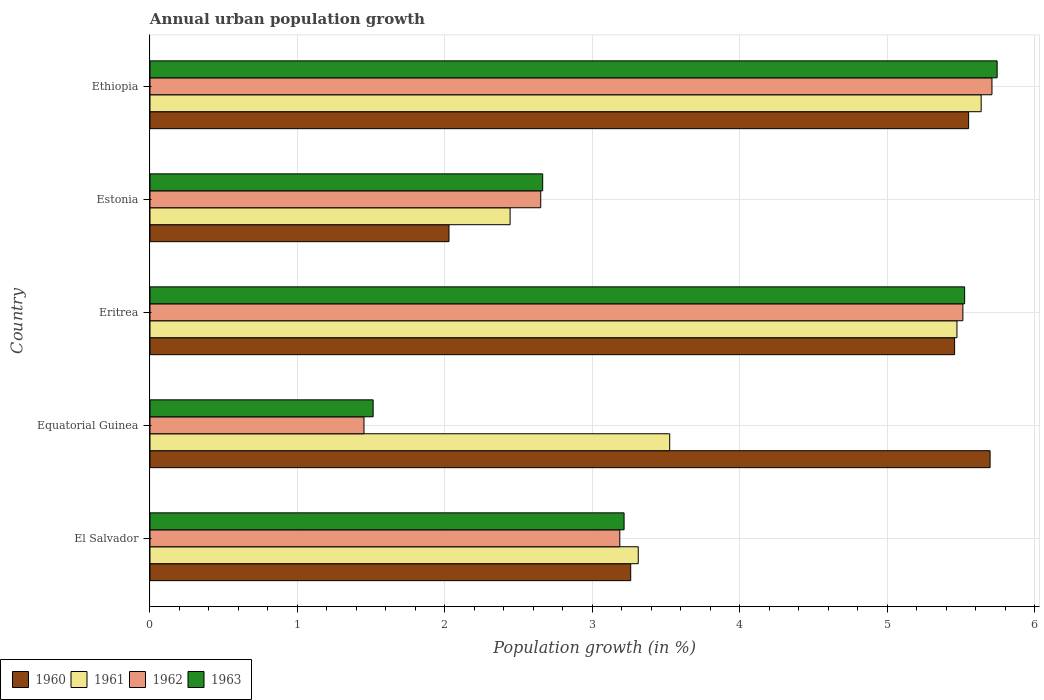How many different coloured bars are there?
Offer a very short reply. 4. What is the label of the 2nd group of bars from the top?
Keep it short and to the point. Estonia. In how many cases, is the number of bars for a given country not equal to the number of legend labels?
Your response must be concise. 0. What is the percentage of urban population growth in 1962 in Estonia?
Make the answer very short. 2.65. Across all countries, what is the maximum percentage of urban population growth in 1962?
Provide a succinct answer. 5.71. Across all countries, what is the minimum percentage of urban population growth in 1960?
Your answer should be compact. 2.03. In which country was the percentage of urban population growth in 1961 maximum?
Keep it short and to the point. Ethiopia. In which country was the percentage of urban population growth in 1961 minimum?
Provide a short and direct response. Estonia. What is the total percentage of urban population growth in 1963 in the graph?
Provide a short and direct response. 18.66. What is the difference between the percentage of urban population growth in 1961 in Estonia and that in Ethiopia?
Your answer should be compact. -3.2. What is the difference between the percentage of urban population growth in 1962 in Ethiopia and the percentage of urban population growth in 1961 in Equatorial Guinea?
Make the answer very short. 2.19. What is the average percentage of urban population growth in 1960 per country?
Give a very brief answer. 4.4. What is the difference between the percentage of urban population growth in 1960 and percentage of urban population growth in 1962 in Estonia?
Provide a succinct answer. -0.62. In how many countries, is the percentage of urban population growth in 1962 greater than 3.4 %?
Ensure brevity in your answer.  2. What is the ratio of the percentage of urban population growth in 1960 in El Salvador to that in Eritrea?
Keep it short and to the point. 0.6. Is the percentage of urban population growth in 1962 in El Salvador less than that in Eritrea?
Give a very brief answer. Yes. What is the difference between the highest and the second highest percentage of urban population growth in 1961?
Provide a succinct answer. 0.16. What is the difference between the highest and the lowest percentage of urban population growth in 1961?
Your response must be concise. 3.2. Is the sum of the percentage of urban population growth in 1963 in Eritrea and Ethiopia greater than the maximum percentage of urban population growth in 1962 across all countries?
Ensure brevity in your answer.  Yes. What does the 2nd bar from the bottom in Ethiopia represents?
Offer a terse response. 1961. Is it the case that in every country, the sum of the percentage of urban population growth in 1961 and percentage of urban population growth in 1960 is greater than the percentage of urban population growth in 1963?
Your answer should be compact. Yes. How many countries are there in the graph?
Offer a terse response. 5. What is the difference between two consecutive major ticks on the X-axis?
Your response must be concise. 1. Are the values on the major ticks of X-axis written in scientific E-notation?
Your answer should be very brief. No. How many legend labels are there?
Offer a terse response. 4. What is the title of the graph?
Offer a terse response. Annual urban population growth. Does "1985" appear as one of the legend labels in the graph?
Offer a very short reply. No. What is the label or title of the X-axis?
Your response must be concise. Population growth (in %). What is the Population growth (in %) of 1960 in El Salvador?
Ensure brevity in your answer.  3.26. What is the Population growth (in %) of 1961 in El Salvador?
Your response must be concise. 3.31. What is the Population growth (in %) in 1962 in El Salvador?
Provide a short and direct response. 3.19. What is the Population growth (in %) in 1963 in El Salvador?
Your response must be concise. 3.22. What is the Population growth (in %) of 1960 in Equatorial Guinea?
Provide a succinct answer. 5.7. What is the Population growth (in %) in 1961 in Equatorial Guinea?
Make the answer very short. 3.53. What is the Population growth (in %) of 1962 in Equatorial Guinea?
Your answer should be compact. 1.45. What is the Population growth (in %) in 1963 in Equatorial Guinea?
Your answer should be very brief. 1.51. What is the Population growth (in %) in 1960 in Eritrea?
Your answer should be very brief. 5.46. What is the Population growth (in %) in 1961 in Eritrea?
Provide a succinct answer. 5.47. What is the Population growth (in %) of 1962 in Eritrea?
Your answer should be very brief. 5.51. What is the Population growth (in %) of 1963 in Eritrea?
Keep it short and to the point. 5.53. What is the Population growth (in %) of 1960 in Estonia?
Offer a very short reply. 2.03. What is the Population growth (in %) in 1961 in Estonia?
Make the answer very short. 2.44. What is the Population growth (in %) in 1962 in Estonia?
Your answer should be compact. 2.65. What is the Population growth (in %) in 1963 in Estonia?
Give a very brief answer. 2.66. What is the Population growth (in %) in 1960 in Ethiopia?
Your response must be concise. 5.55. What is the Population growth (in %) of 1961 in Ethiopia?
Make the answer very short. 5.64. What is the Population growth (in %) of 1962 in Ethiopia?
Offer a terse response. 5.71. What is the Population growth (in %) in 1963 in Ethiopia?
Keep it short and to the point. 5.75. Across all countries, what is the maximum Population growth (in %) of 1960?
Offer a very short reply. 5.7. Across all countries, what is the maximum Population growth (in %) of 1961?
Ensure brevity in your answer.  5.64. Across all countries, what is the maximum Population growth (in %) of 1962?
Provide a short and direct response. 5.71. Across all countries, what is the maximum Population growth (in %) of 1963?
Your answer should be compact. 5.75. Across all countries, what is the minimum Population growth (in %) of 1960?
Your response must be concise. 2.03. Across all countries, what is the minimum Population growth (in %) in 1961?
Ensure brevity in your answer.  2.44. Across all countries, what is the minimum Population growth (in %) of 1962?
Offer a very short reply. 1.45. Across all countries, what is the minimum Population growth (in %) of 1963?
Your response must be concise. 1.51. What is the total Population growth (in %) in 1960 in the graph?
Your response must be concise. 22. What is the total Population growth (in %) in 1961 in the graph?
Offer a very short reply. 20.39. What is the total Population growth (in %) of 1962 in the graph?
Provide a succinct answer. 18.51. What is the total Population growth (in %) in 1963 in the graph?
Ensure brevity in your answer.  18.66. What is the difference between the Population growth (in %) of 1960 in El Salvador and that in Equatorial Guinea?
Give a very brief answer. -2.44. What is the difference between the Population growth (in %) of 1961 in El Salvador and that in Equatorial Guinea?
Offer a terse response. -0.21. What is the difference between the Population growth (in %) in 1962 in El Salvador and that in Equatorial Guinea?
Make the answer very short. 1.74. What is the difference between the Population growth (in %) in 1963 in El Salvador and that in Equatorial Guinea?
Offer a terse response. 1.7. What is the difference between the Population growth (in %) of 1960 in El Salvador and that in Eritrea?
Give a very brief answer. -2.2. What is the difference between the Population growth (in %) of 1961 in El Salvador and that in Eritrea?
Offer a very short reply. -2.16. What is the difference between the Population growth (in %) of 1962 in El Salvador and that in Eritrea?
Offer a very short reply. -2.33. What is the difference between the Population growth (in %) of 1963 in El Salvador and that in Eritrea?
Make the answer very short. -2.31. What is the difference between the Population growth (in %) of 1960 in El Salvador and that in Estonia?
Provide a succinct answer. 1.23. What is the difference between the Population growth (in %) of 1961 in El Salvador and that in Estonia?
Provide a short and direct response. 0.87. What is the difference between the Population growth (in %) in 1962 in El Salvador and that in Estonia?
Your answer should be compact. 0.54. What is the difference between the Population growth (in %) of 1963 in El Salvador and that in Estonia?
Provide a short and direct response. 0.55. What is the difference between the Population growth (in %) of 1960 in El Salvador and that in Ethiopia?
Keep it short and to the point. -2.29. What is the difference between the Population growth (in %) in 1961 in El Salvador and that in Ethiopia?
Provide a short and direct response. -2.33. What is the difference between the Population growth (in %) in 1962 in El Salvador and that in Ethiopia?
Offer a very short reply. -2.52. What is the difference between the Population growth (in %) in 1963 in El Salvador and that in Ethiopia?
Your answer should be compact. -2.53. What is the difference between the Population growth (in %) in 1960 in Equatorial Guinea and that in Eritrea?
Provide a short and direct response. 0.24. What is the difference between the Population growth (in %) in 1961 in Equatorial Guinea and that in Eritrea?
Give a very brief answer. -1.95. What is the difference between the Population growth (in %) of 1962 in Equatorial Guinea and that in Eritrea?
Make the answer very short. -4.06. What is the difference between the Population growth (in %) of 1963 in Equatorial Guinea and that in Eritrea?
Your answer should be compact. -4.01. What is the difference between the Population growth (in %) of 1960 in Equatorial Guinea and that in Estonia?
Your answer should be very brief. 3.67. What is the difference between the Population growth (in %) in 1961 in Equatorial Guinea and that in Estonia?
Keep it short and to the point. 1.08. What is the difference between the Population growth (in %) of 1962 in Equatorial Guinea and that in Estonia?
Ensure brevity in your answer.  -1.2. What is the difference between the Population growth (in %) of 1963 in Equatorial Guinea and that in Estonia?
Keep it short and to the point. -1.15. What is the difference between the Population growth (in %) in 1960 in Equatorial Guinea and that in Ethiopia?
Keep it short and to the point. 0.15. What is the difference between the Population growth (in %) in 1961 in Equatorial Guinea and that in Ethiopia?
Keep it short and to the point. -2.11. What is the difference between the Population growth (in %) of 1962 in Equatorial Guinea and that in Ethiopia?
Offer a very short reply. -4.26. What is the difference between the Population growth (in %) in 1963 in Equatorial Guinea and that in Ethiopia?
Your answer should be very brief. -4.23. What is the difference between the Population growth (in %) of 1960 in Eritrea and that in Estonia?
Keep it short and to the point. 3.43. What is the difference between the Population growth (in %) of 1961 in Eritrea and that in Estonia?
Provide a short and direct response. 3.03. What is the difference between the Population growth (in %) of 1962 in Eritrea and that in Estonia?
Offer a very short reply. 2.86. What is the difference between the Population growth (in %) in 1963 in Eritrea and that in Estonia?
Make the answer very short. 2.86. What is the difference between the Population growth (in %) of 1960 in Eritrea and that in Ethiopia?
Offer a terse response. -0.1. What is the difference between the Population growth (in %) in 1961 in Eritrea and that in Ethiopia?
Provide a short and direct response. -0.16. What is the difference between the Population growth (in %) of 1962 in Eritrea and that in Ethiopia?
Offer a very short reply. -0.2. What is the difference between the Population growth (in %) of 1963 in Eritrea and that in Ethiopia?
Make the answer very short. -0.22. What is the difference between the Population growth (in %) in 1960 in Estonia and that in Ethiopia?
Ensure brevity in your answer.  -3.52. What is the difference between the Population growth (in %) in 1961 in Estonia and that in Ethiopia?
Your answer should be compact. -3.19. What is the difference between the Population growth (in %) of 1962 in Estonia and that in Ethiopia?
Provide a short and direct response. -3.06. What is the difference between the Population growth (in %) of 1963 in Estonia and that in Ethiopia?
Make the answer very short. -3.08. What is the difference between the Population growth (in %) in 1960 in El Salvador and the Population growth (in %) in 1961 in Equatorial Guinea?
Keep it short and to the point. -0.26. What is the difference between the Population growth (in %) of 1960 in El Salvador and the Population growth (in %) of 1962 in Equatorial Guinea?
Make the answer very short. 1.81. What is the difference between the Population growth (in %) of 1960 in El Salvador and the Population growth (in %) of 1963 in Equatorial Guinea?
Provide a succinct answer. 1.75. What is the difference between the Population growth (in %) of 1961 in El Salvador and the Population growth (in %) of 1962 in Equatorial Guinea?
Your answer should be compact. 1.86. What is the difference between the Population growth (in %) of 1961 in El Salvador and the Population growth (in %) of 1963 in Equatorial Guinea?
Ensure brevity in your answer.  1.8. What is the difference between the Population growth (in %) of 1962 in El Salvador and the Population growth (in %) of 1963 in Equatorial Guinea?
Keep it short and to the point. 1.67. What is the difference between the Population growth (in %) in 1960 in El Salvador and the Population growth (in %) in 1961 in Eritrea?
Offer a very short reply. -2.21. What is the difference between the Population growth (in %) in 1960 in El Salvador and the Population growth (in %) in 1962 in Eritrea?
Give a very brief answer. -2.25. What is the difference between the Population growth (in %) in 1960 in El Salvador and the Population growth (in %) in 1963 in Eritrea?
Your answer should be compact. -2.26. What is the difference between the Population growth (in %) in 1961 in El Salvador and the Population growth (in %) in 1962 in Eritrea?
Your answer should be very brief. -2.2. What is the difference between the Population growth (in %) of 1961 in El Salvador and the Population growth (in %) of 1963 in Eritrea?
Offer a terse response. -2.21. What is the difference between the Population growth (in %) in 1962 in El Salvador and the Population growth (in %) in 1963 in Eritrea?
Provide a succinct answer. -2.34. What is the difference between the Population growth (in %) of 1960 in El Salvador and the Population growth (in %) of 1961 in Estonia?
Provide a short and direct response. 0.82. What is the difference between the Population growth (in %) in 1960 in El Salvador and the Population growth (in %) in 1962 in Estonia?
Provide a short and direct response. 0.61. What is the difference between the Population growth (in %) in 1960 in El Salvador and the Population growth (in %) in 1963 in Estonia?
Your answer should be very brief. 0.6. What is the difference between the Population growth (in %) in 1961 in El Salvador and the Population growth (in %) in 1962 in Estonia?
Provide a short and direct response. 0.66. What is the difference between the Population growth (in %) in 1961 in El Salvador and the Population growth (in %) in 1963 in Estonia?
Make the answer very short. 0.65. What is the difference between the Population growth (in %) of 1962 in El Salvador and the Population growth (in %) of 1963 in Estonia?
Provide a short and direct response. 0.52. What is the difference between the Population growth (in %) of 1960 in El Salvador and the Population growth (in %) of 1961 in Ethiopia?
Offer a terse response. -2.38. What is the difference between the Population growth (in %) of 1960 in El Salvador and the Population growth (in %) of 1962 in Ethiopia?
Keep it short and to the point. -2.45. What is the difference between the Population growth (in %) in 1960 in El Salvador and the Population growth (in %) in 1963 in Ethiopia?
Your answer should be very brief. -2.49. What is the difference between the Population growth (in %) of 1961 in El Salvador and the Population growth (in %) of 1962 in Ethiopia?
Keep it short and to the point. -2.4. What is the difference between the Population growth (in %) in 1961 in El Salvador and the Population growth (in %) in 1963 in Ethiopia?
Offer a terse response. -2.43. What is the difference between the Population growth (in %) of 1962 in El Salvador and the Population growth (in %) of 1963 in Ethiopia?
Keep it short and to the point. -2.56. What is the difference between the Population growth (in %) in 1960 in Equatorial Guinea and the Population growth (in %) in 1961 in Eritrea?
Keep it short and to the point. 0.22. What is the difference between the Population growth (in %) of 1960 in Equatorial Guinea and the Population growth (in %) of 1962 in Eritrea?
Offer a terse response. 0.18. What is the difference between the Population growth (in %) of 1960 in Equatorial Guinea and the Population growth (in %) of 1963 in Eritrea?
Your answer should be compact. 0.17. What is the difference between the Population growth (in %) of 1961 in Equatorial Guinea and the Population growth (in %) of 1962 in Eritrea?
Provide a succinct answer. -1.99. What is the difference between the Population growth (in %) in 1961 in Equatorial Guinea and the Population growth (in %) in 1963 in Eritrea?
Provide a succinct answer. -2. What is the difference between the Population growth (in %) in 1962 in Equatorial Guinea and the Population growth (in %) in 1963 in Eritrea?
Offer a terse response. -4.07. What is the difference between the Population growth (in %) in 1960 in Equatorial Guinea and the Population growth (in %) in 1961 in Estonia?
Your answer should be very brief. 3.26. What is the difference between the Population growth (in %) of 1960 in Equatorial Guinea and the Population growth (in %) of 1962 in Estonia?
Your answer should be very brief. 3.05. What is the difference between the Population growth (in %) of 1960 in Equatorial Guinea and the Population growth (in %) of 1963 in Estonia?
Give a very brief answer. 3.03. What is the difference between the Population growth (in %) of 1961 in Equatorial Guinea and the Population growth (in %) of 1962 in Estonia?
Provide a short and direct response. 0.87. What is the difference between the Population growth (in %) in 1961 in Equatorial Guinea and the Population growth (in %) in 1963 in Estonia?
Keep it short and to the point. 0.86. What is the difference between the Population growth (in %) in 1962 in Equatorial Guinea and the Population growth (in %) in 1963 in Estonia?
Ensure brevity in your answer.  -1.21. What is the difference between the Population growth (in %) of 1960 in Equatorial Guinea and the Population growth (in %) of 1961 in Ethiopia?
Your answer should be compact. 0.06. What is the difference between the Population growth (in %) in 1960 in Equatorial Guinea and the Population growth (in %) in 1962 in Ethiopia?
Your answer should be compact. -0.01. What is the difference between the Population growth (in %) in 1960 in Equatorial Guinea and the Population growth (in %) in 1963 in Ethiopia?
Your answer should be very brief. -0.05. What is the difference between the Population growth (in %) in 1961 in Equatorial Guinea and the Population growth (in %) in 1962 in Ethiopia?
Offer a terse response. -2.19. What is the difference between the Population growth (in %) of 1961 in Equatorial Guinea and the Population growth (in %) of 1963 in Ethiopia?
Keep it short and to the point. -2.22. What is the difference between the Population growth (in %) of 1962 in Equatorial Guinea and the Population growth (in %) of 1963 in Ethiopia?
Your response must be concise. -4.29. What is the difference between the Population growth (in %) in 1960 in Eritrea and the Population growth (in %) in 1961 in Estonia?
Your answer should be very brief. 3.01. What is the difference between the Population growth (in %) in 1960 in Eritrea and the Population growth (in %) in 1962 in Estonia?
Give a very brief answer. 2.81. What is the difference between the Population growth (in %) in 1960 in Eritrea and the Population growth (in %) in 1963 in Estonia?
Keep it short and to the point. 2.79. What is the difference between the Population growth (in %) of 1961 in Eritrea and the Population growth (in %) of 1962 in Estonia?
Offer a terse response. 2.82. What is the difference between the Population growth (in %) in 1961 in Eritrea and the Population growth (in %) in 1963 in Estonia?
Your answer should be compact. 2.81. What is the difference between the Population growth (in %) in 1962 in Eritrea and the Population growth (in %) in 1963 in Estonia?
Your answer should be very brief. 2.85. What is the difference between the Population growth (in %) of 1960 in Eritrea and the Population growth (in %) of 1961 in Ethiopia?
Your response must be concise. -0.18. What is the difference between the Population growth (in %) in 1960 in Eritrea and the Population growth (in %) in 1962 in Ethiopia?
Give a very brief answer. -0.25. What is the difference between the Population growth (in %) in 1960 in Eritrea and the Population growth (in %) in 1963 in Ethiopia?
Ensure brevity in your answer.  -0.29. What is the difference between the Population growth (in %) of 1961 in Eritrea and the Population growth (in %) of 1962 in Ethiopia?
Provide a short and direct response. -0.24. What is the difference between the Population growth (in %) in 1961 in Eritrea and the Population growth (in %) in 1963 in Ethiopia?
Provide a succinct answer. -0.27. What is the difference between the Population growth (in %) of 1962 in Eritrea and the Population growth (in %) of 1963 in Ethiopia?
Keep it short and to the point. -0.23. What is the difference between the Population growth (in %) in 1960 in Estonia and the Population growth (in %) in 1961 in Ethiopia?
Give a very brief answer. -3.61. What is the difference between the Population growth (in %) in 1960 in Estonia and the Population growth (in %) in 1962 in Ethiopia?
Keep it short and to the point. -3.68. What is the difference between the Population growth (in %) of 1960 in Estonia and the Population growth (in %) of 1963 in Ethiopia?
Your answer should be very brief. -3.72. What is the difference between the Population growth (in %) in 1961 in Estonia and the Population growth (in %) in 1962 in Ethiopia?
Provide a succinct answer. -3.27. What is the difference between the Population growth (in %) of 1961 in Estonia and the Population growth (in %) of 1963 in Ethiopia?
Offer a terse response. -3.3. What is the difference between the Population growth (in %) in 1962 in Estonia and the Population growth (in %) in 1963 in Ethiopia?
Your answer should be compact. -3.1. What is the average Population growth (in %) of 1960 per country?
Ensure brevity in your answer.  4.4. What is the average Population growth (in %) of 1961 per country?
Ensure brevity in your answer.  4.08. What is the average Population growth (in %) of 1962 per country?
Your answer should be very brief. 3.7. What is the average Population growth (in %) of 1963 per country?
Your response must be concise. 3.73. What is the difference between the Population growth (in %) in 1960 and Population growth (in %) in 1961 in El Salvador?
Your response must be concise. -0.05. What is the difference between the Population growth (in %) of 1960 and Population growth (in %) of 1962 in El Salvador?
Your answer should be compact. 0.07. What is the difference between the Population growth (in %) of 1960 and Population growth (in %) of 1963 in El Salvador?
Offer a terse response. 0.04. What is the difference between the Population growth (in %) of 1961 and Population growth (in %) of 1963 in El Salvador?
Make the answer very short. 0.1. What is the difference between the Population growth (in %) in 1962 and Population growth (in %) in 1963 in El Salvador?
Provide a short and direct response. -0.03. What is the difference between the Population growth (in %) in 1960 and Population growth (in %) in 1961 in Equatorial Guinea?
Make the answer very short. 2.17. What is the difference between the Population growth (in %) of 1960 and Population growth (in %) of 1962 in Equatorial Guinea?
Your answer should be very brief. 4.25. What is the difference between the Population growth (in %) in 1960 and Population growth (in %) in 1963 in Equatorial Guinea?
Keep it short and to the point. 4.18. What is the difference between the Population growth (in %) in 1961 and Population growth (in %) in 1962 in Equatorial Guinea?
Your answer should be very brief. 2.07. What is the difference between the Population growth (in %) in 1961 and Population growth (in %) in 1963 in Equatorial Guinea?
Offer a terse response. 2.01. What is the difference between the Population growth (in %) in 1962 and Population growth (in %) in 1963 in Equatorial Guinea?
Give a very brief answer. -0.06. What is the difference between the Population growth (in %) in 1960 and Population growth (in %) in 1961 in Eritrea?
Provide a short and direct response. -0.02. What is the difference between the Population growth (in %) in 1960 and Population growth (in %) in 1962 in Eritrea?
Offer a very short reply. -0.06. What is the difference between the Population growth (in %) of 1960 and Population growth (in %) of 1963 in Eritrea?
Keep it short and to the point. -0.07. What is the difference between the Population growth (in %) in 1961 and Population growth (in %) in 1962 in Eritrea?
Keep it short and to the point. -0.04. What is the difference between the Population growth (in %) of 1961 and Population growth (in %) of 1963 in Eritrea?
Ensure brevity in your answer.  -0.05. What is the difference between the Population growth (in %) in 1962 and Population growth (in %) in 1963 in Eritrea?
Your response must be concise. -0.01. What is the difference between the Population growth (in %) of 1960 and Population growth (in %) of 1961 in Estonia?
Offer a terse response. -0.41. What is the difference between the Population growth (in %) of 1960 and Population growth (in %) of 1962 in Estonia?
Your answer should be compact. -0.62. What is the difference between the Population growth (in %) in 1960 and Population growth (in %) in 1963 in Estonia?
Offer a terse response. -0.64. What is the difference between the Population growth (in %) in 1961 and Population growth (in %) in 1962 in Estonia?
Your answer should be compact. -0.21. What is the difference between the Population growth (in %) in 1961 and Population growth (in %) in 1963 in Estonia?
Provide a succinct answer. -0.22. What is the difference between the Population growth (in %) of 1962 and Population growth (in %) of 1963 in Estonia?
Provide a succinct answer. -0.01. What is the difference between the Population growth (in %) in 1960 and Population growth (in %) in 1961 in Ethiopia?
Give a very brief answer. -0.09. What is the difference between the Population growth (in %) of 1960 and Population growth (in %) of 1962 in Ethiopia?
Your answer should be compact. -0.16. What is the difference between the Population growth (in %) of 1960 and Population growth (in %) of 1963 in Ethiopia?
Provide a short and direct response. -0.19. What is the difference between the Population growth (in %) of 1961 and Population growth (in %) of 1962 in Ethiopia?
Your answer should be compact. -0.07. What is the difference between the Population growth (in %) in 1961 and Population growth (in %) in 1963 in Ethiopia?
Make the answer very short. -0.11. What is the difference between the Population growth (in %) of 1962 and Population growth (in %) of 1963 in Ethiopia?
Provide a succinct answer. -0.04. What is the ratio of the Population growth (in %) in 1960 in El Salvador to that in Equatorial Guinea?
Offer a terse response. 0.57. What is the ratio of the Population growth (in %) in 1961 in El Salvador to that in Equatorial Guinea?
Ensure brevity in your answer.  0.94. What is the ratio of the Population growth (in %) of 1962 in El Salvador to that in Equatorial Guinea?
Give a very brief answer. 2.2. What is the ratio of the Population growth (in %) in 1963 in El Salvador to that in Equatorial Guinea?
Your answer should be very brief. 2.12. What is the ratio of the Population growth (in %) of 1960 in El Salvador to that in Eritrea?
Your answer should be very brief. 0.6. What is the ratio of the Population growth (in %) of 1961 in El Salvador to that in Eritrea?
Make the answer very short. 0.6. What is the ratio of the Population growth (in %) of 1962 in El Salvador to that in Eritrea?
Your answer should be compact. 0.58. What is the ratio of the Population growth (in %) of 1963 in El Salvador to that in Eritrea?
Your answer should be compact. 0.58. What is the ratio of the Population growth (in %) in 1960 in El Salvador to that in Estonia?
Provide a short and direct response. 1.61. What is the ratio of the Population growth (in %) in 1961 in El Salvador to that in Estonia?
Ensure brevity in your answer.  1.36. What is the ratio of the Population growth (in %) of 1962 in El Salvador to that in Estonia?
Ensure brevity in your answer.  1.2. What is the ratio of the Population growth (in %) in 1963 in El Salvador to that in Estonia?
Your answer should be very brief. 1.21. What is the ratio of the Population growth (in %) of 1960 in El Salvador to that in Ethiopia?
Give a very brief answer. 0.59. What is the ratio of the Population growth (in %) in 1961 in El Salvador to that in Ethiopia?
Make the answer very short. 0.59. What is the ratio of the Population growth (in %) in 1962 in El Salvador to that in Ethiopia?
Give a very brief answer. 0.56. What is the ratio of the Population growth (in %) of 1963 in El Salvador to that in Ethiopia?
Give a very brief answer. 0.56. What is the ratio of the Population growth (in %) of 1960 in Equatorial Guinea to that in Eritrea?
Provide a succinct answer. 1.04. What is the ratio of the Population growth (in %) of 1961 in Equatorial Guinea to that in Eritrea?
Your answer should be compact. 0.64. What is the ratio of the Population growth (in %) of 1962 in Equatorial Guinea to that in Eritrea?
Offer a terse response. 0.26. What is the ratio of the Population growth (in %) of 1963 in Equatorial Guinea to that in Eritrea?
Your answer should be very brief. 0.27. What is the ratio of the Population growth (in %) in 1960 in Equatorial Guinea to that in Estonia?
Your answer should be compact. 2.81. What is the ratio of the Population growth (in %) of 1961 in Equatorial Guinea to that in Estonia?
Your answer should be very brief. 1.44. What is the ratio of the Population growth (in %) of 1962 in Equatorial Guinea to that in Estonia?
Your answer should be compact. 0.55. What is the ratio of the Population growth (in %) of 1963 in Equatorial Guinea to that in Estonia?
Provide a succinct answer. 0.57. What is the ratio of the Population growth (in %) in 1960 in Equatorial Guinea to that in Ethiopia?
Offer a terse response. 1.03. What is the ratio of the Population growth (in %) of 1961 in Equatorial Guinea to that in Ethiopia?
Provide a succinct answer. 0.63. What is the ratio of the Population growth (in %) of 1962 in Equatorial Guinea to that in Ethiopia?
Keep it short and to the point. 0.25. What is the ratio of the Population growth (in %) of 1963 in Equatorial Guinea to that in Ethiopia?
Offer a terse response. 0.26. What is the ratio of the Population growth (in %) of 1960 in Eritrea to that in Estonia?
Give a very brief answer. 2.69. What is the ratio of the Population growth (in %) of 1961 in Eritrea to that in Estonia?
Keep it short and to the point. 2.24. What is the ratio of the Population growth (in %) in 1962 in Eritrea to that in Estonia?
Your answer should be very brief. 2.08. What is the ratio of the Population growth (in %) of 1963 in Eritrea to that in Estonia?
Your answer should be very brief. 2.07. What is the ratio of the Population growth (in %) in 1960 in Eritrea to that in Ethiopia?
Your answer should be very brief. 0.98. What is the ratio of the Population growth (in %) of 1961 in Eritrea to that in Ethiopia?
Offer a terse response. 0.97. What is the ratio of the Population growth (in %) in 1962 in Eritrea to that in Ethiopia?
Provide a short and direct response. 0.97. What is the ratio of the Population growth (in %) in 1963 in Eritrea to that in Ethiopia?
Offer a very short reply. 0.96. What is the ratio of the Population growth (in %) in 1960 in Estonia to that in Ethiopia?
Provide a succinct answer. 0.37. What is the ratio of the Population growth (in %) of 1961 in Estonia to that in Ethiopia?
Provide a succinct answer. 0.43. What is the ratio of the Population growth (in %) in 1962 in Estonia to that in Ethiopia?
Give a very brief answer. 0.46. What is the ratio of the Population growth (in %) of 1963 in Estonia to that in Ethiopia?
Ensure brevity in your answer.  0.46. What is the difference between the highest and the second highest Population growth (in %) of 1960?
Make the answer very short. 0.15. What is the difference between the highest and the second highest Population growth (in %) in 1961?
Keep it short and to the point. 0.16. What is the difference between the highest and the second highest Population growth (in %) in 1962?
Make the answer very short. 0.2. What is the difference between the highest and the second highest Population growth (in %) in 1963?
Your response must be concise. 0.22. What is the difference between the highest and the lowest Population growth (in %) of 1960?
Ensure brevity in your answer.  3.67. What is the difference between the highest and the lowest Population growth (in %) in 1961?
Ensure brevity in your answer.  3.19. What is the difference between the highest and the lowest Population growth (in %) of 1962?
Offer a very short reply. 4.26. What is the difference between the highest and the lowest Population growth (in %) in 1963?
Your response must be concise. 4.23. 